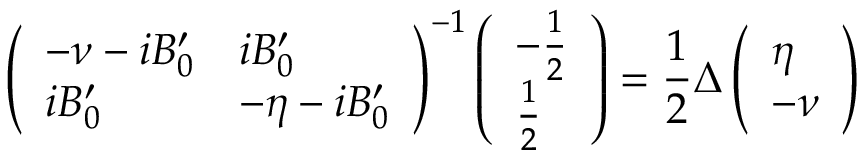<formula> <loc_0><loc_0><loc_500><loc_500>\left ( \begin{array} { l l } { - \nu - i B _ { 0 } ^ { \prime } } & { i B _ { 0 } ^ { \prime } } \\ { i B _ { 0 } ^ { \prime } } & { - \eta - i B _ { 0 } ^ { \prime } } \end{array} \right ) ^ { - 1 } \left ( \begin{array} { l } { - \frac { 1 } { 2 } } \\ { \frac { 1 } { 2 } } \end{array} \right ) = \frac { 1 } { 2 } \Delta \left ( \begin{array} { l } { \eta } \\ { - \nu } \end{array} \right )</formula> 